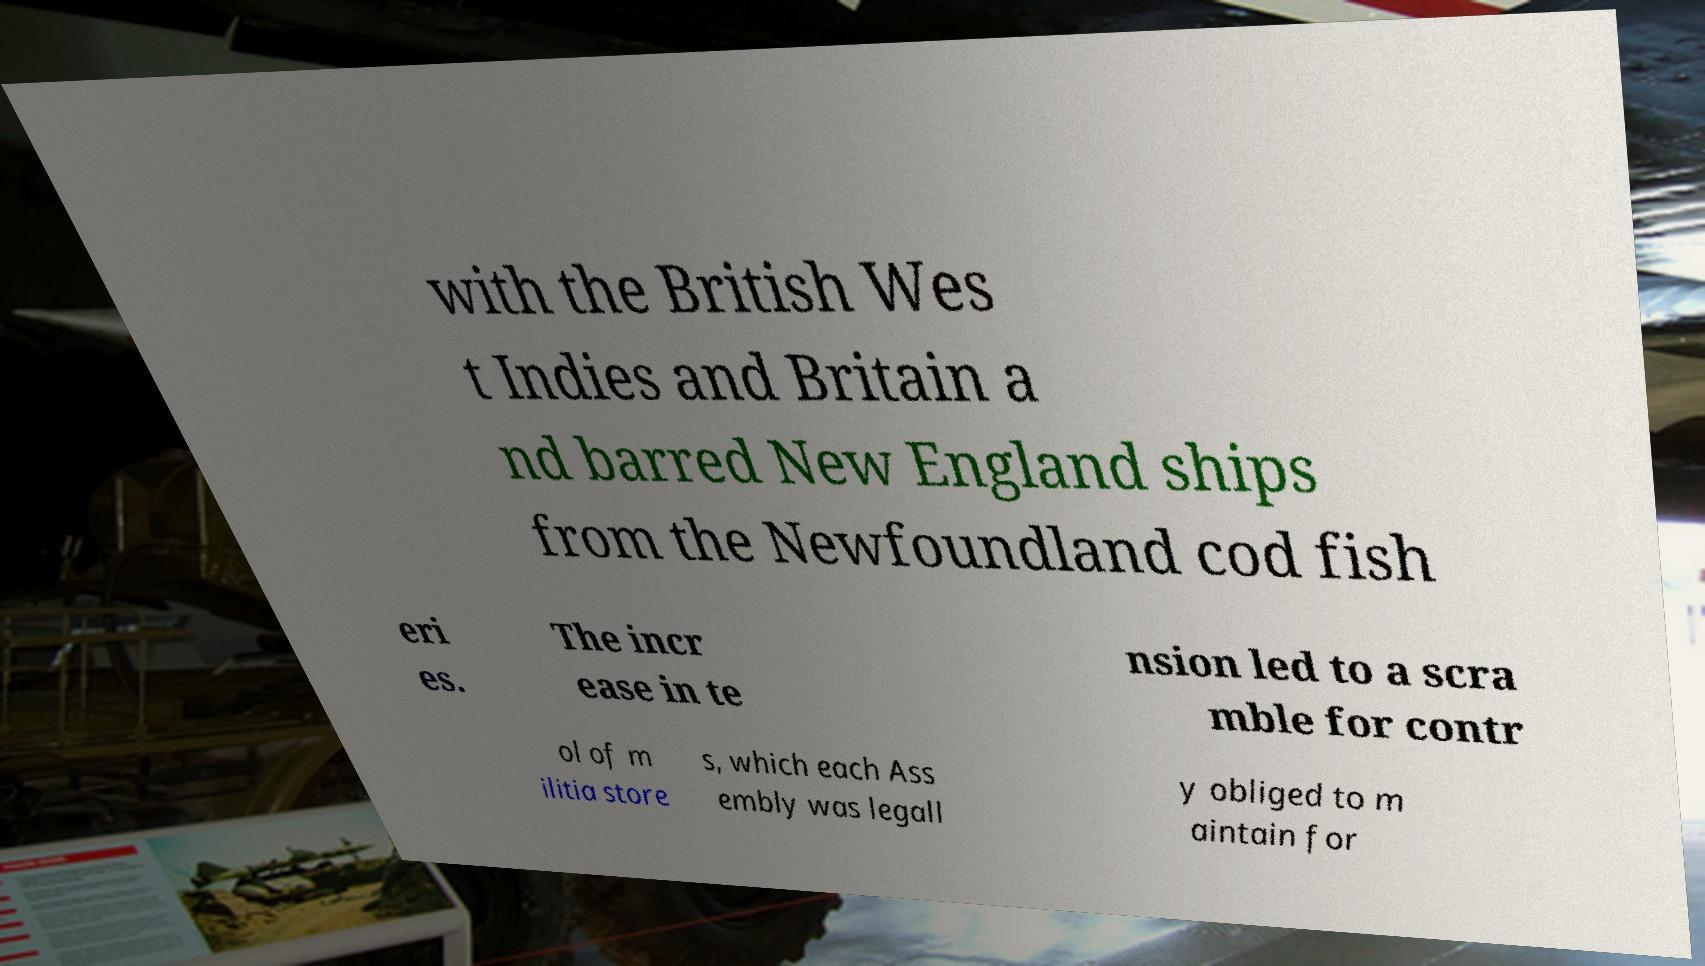Could you extract and type out the text from this image? with the British Wes t Indies and Britain a nd barred New England ships from the Newfoundland cod fish eri es. The incr ease in te nsion led to a scra mble for contr ol of m ilitia store s, which each Ass embly was legall y obliged to m aintain for 